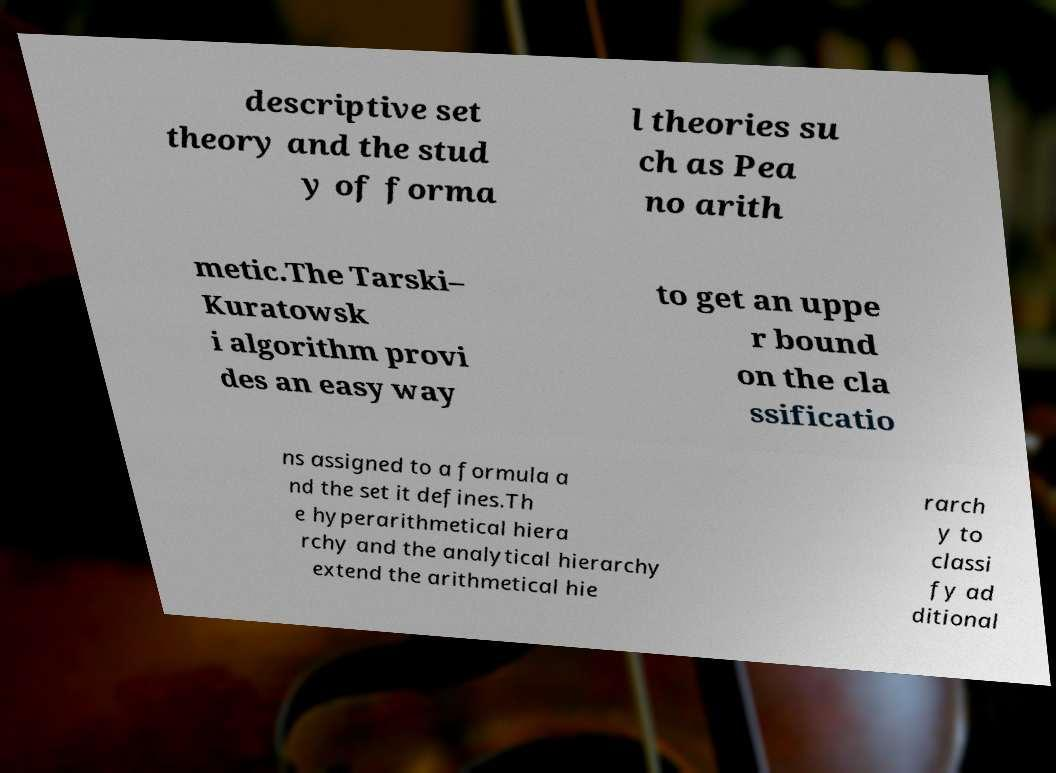There's text embedded in this image that I need extracted. Can you transcribe it verbatim? descriptive set theory and the stud y of forma l theories su ch as Pea no arith metic.The Tarski– Kuratowsk i algorithm provi des an easy way to get an uppe r bound on the cla ssificatio ns assigned to a formula a nd the set it defines.Th e hyperarithmetical hiera rchy and the analytical hierarchy extend the arithmetical hie rarch y to classi fy ad ditional 